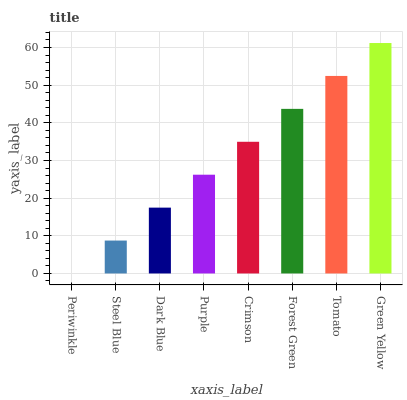Is Steel Blue the minimum?
Answer yes or no. No. Is Steel Blue the maximum?
Answer yes or no. No. Is Steel Blue greater than Periwinkle?
Answer yes or no. Yes. Is Periwinkle less than Steel Blue?
Answer yes or no. Yes. Is Periwinkle greater than Steel Blue?
Answer yes or no. No. Is Steel Blue less than Periwinkle?
Answer yes or no. No. Is Crimson the high median?
Answer yes or no. Yes. Is Purple the low median?
Answer yes or no. Yes. Is Forest Green the high median?
Answer yes or no. No. Is Forest Green the low median?
Answer yes or no. No. 